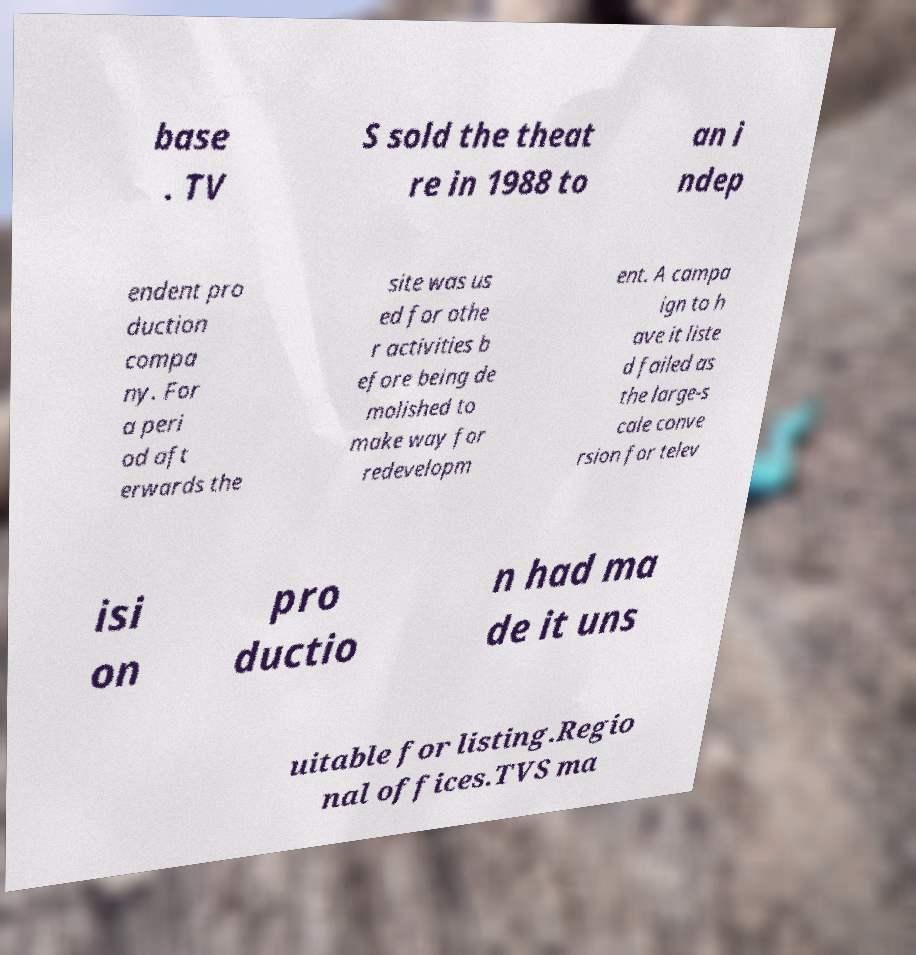For documentation purposes, I need the text within this image transcribed. Could you provide that? base . TV S sold the theat re in 1988 to an i ndep endent pro duction compa ny. For a peri od aft erwards the site was us ed for othe r activities b efore being de molished to make way for redevelopm ent. A campa ign to h ave it liste d failed as the large-s cale conve rsion for telev isi on pro ductio n had ma de it uns uitable for listing.Regio nal offices.TVS ma 